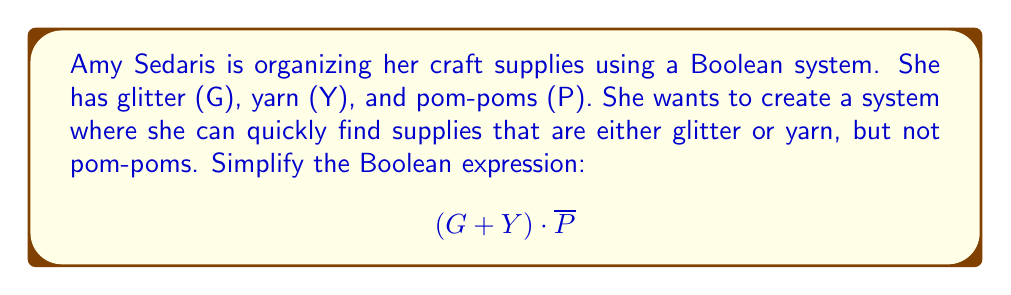Show me your answer to this math problem. Let's simplify this Boolean expression step by step:

1) We start with the expression: $$(G + Y) \cdot \overline{P}$$

2) This expression is already in its simplest form. Here's why:
   - $(G + Y)$ represents "glitter or yarn"
   - $\overline{P}$ represents "not pom-poms"
   - The dot (·) represents AND, so we're looking for items that are (glitter or yarn) AND (not pom-poms)

3) We can't simplify this further because:
   - There are no repeated terms to combine
   - There are no complementary terms to eliminate
   - The distributive property doesn't apply here as it wouldn't simplify the expression

4) Therefore, $$(G + Y) \cdot \overline{P}$$ is the simplest form of this Boolean expression.

This expression perfectly represents Amy's organizational system: it will be true (1) for items that are either glitter or yarn, but not pom-poms, and false (0) for everything else.
Answer: $$(G + Y) \cdot \overline{P}$$ 